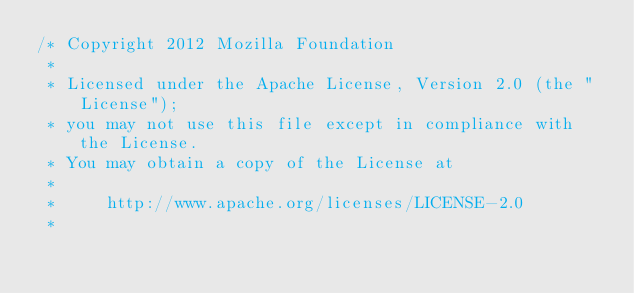<code> <loc_0><loc_0><loc_500><loc_500><_JavaScript_>/* Copyright 2012 Mozilla Foundation
 *
 * Licensed under the Apache License, Version 2.0 (the "License");
 * you may not use this file except in compliance with the License.
 * You may obtain a copy of the License at
 *
 *     http://www.apache.org/licenses/LICENSE-2.0
 *</code> 